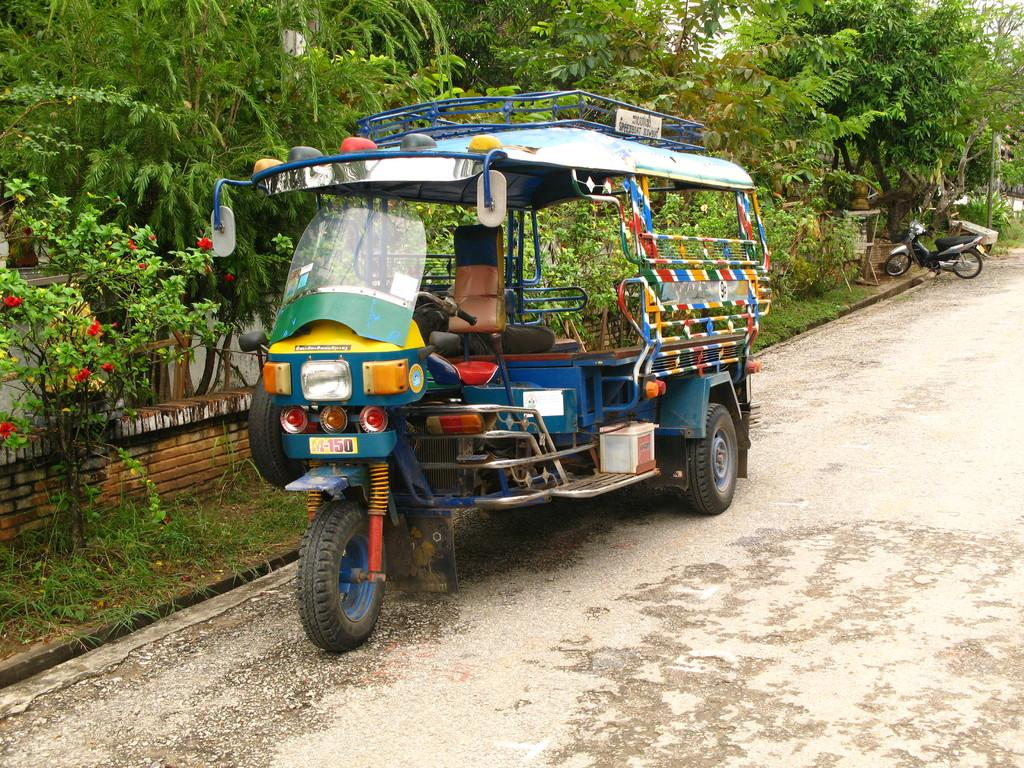What type of vehicle is in the image? There is a colorful auto rickshaw in the image. What is located beside the auto rickshaw? There are plants beside the auto rickshaw. What can be seen in the image that might be used for support or safety? There are railings in the image. What type of vegetation is visible in the image? There are trees in the image. What other mode of transportation can be seen behind the auto rickshaw? There is a bike behind the auto rickshaw. What type of coach is visible in the image? There is no coach present in the image; it features a colorful auto rickshaw and a bike. What type of light source is illuminating the image? The image does not depict a light source; it is a still image. 